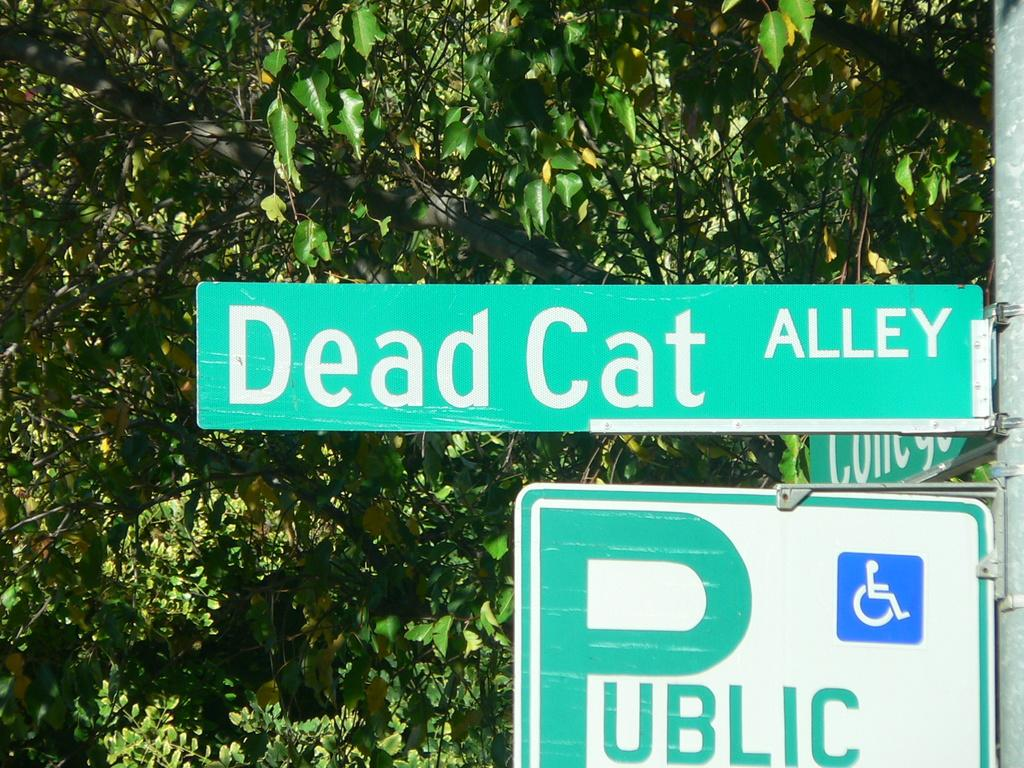<image>
Render a clear and concise summary of the photo. Public sign under a street sign that says Dead Cat. 